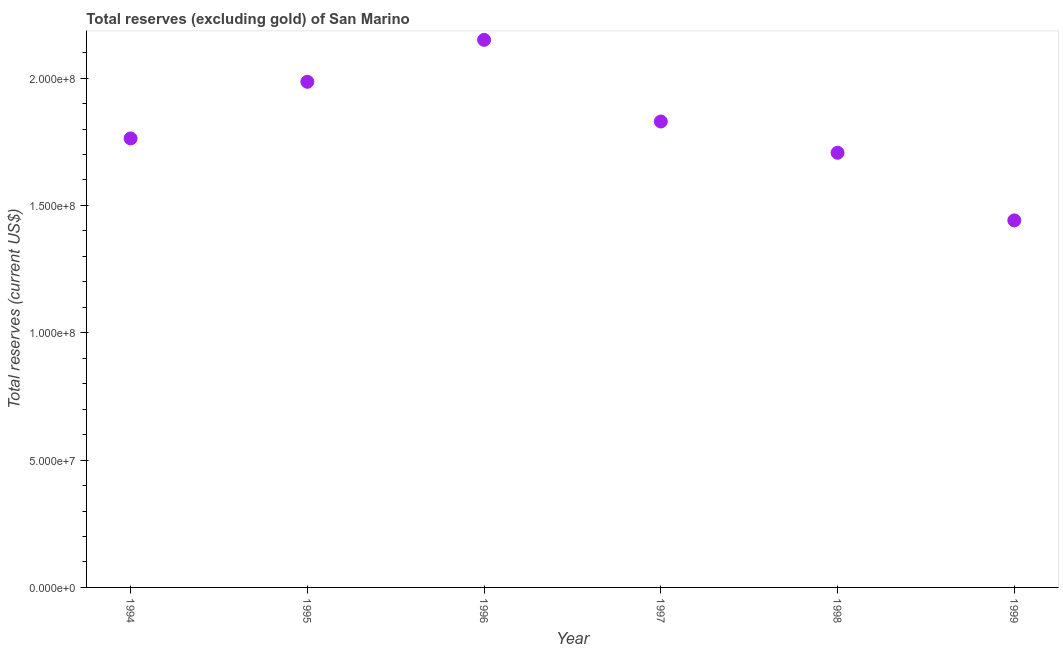What is the total reserves (excluding gold) in 1994?
Provide a short and direct response. 1.76e+08. Across all years, what is the maximum total reserves (excluding gold)?
Your answer should be very brief. 2.15e+08. Across all years, what is the minimum total reserves (excluding gold)?
Your answer should be very brief. 1.44e+08. In which year was the total reserves (excluding gold) maximum?
Offer a very short reply. 1996. In which year was the total reserves (excluding gold) minimum?
Your answer should be very brief. 1999. What is the sum of the total reserves (excluding gold)?
Provide a short and direct response. 1.09e+09. What is the difference between the total reserves (excluding gold) in 1998 and 1999?
Make the answer very short. 2.65e+07. What is the average total reserves (excluding gold) per year?
Keep it short and to the point. 1.81e+08. What is the median total reserves (excluding gold)?
Ensure brevity in your answer.  1.80e+08. In how many years, is the total reserves (excluding gold) greater than 70000000 US$?
Your answer should be compact. 6. Do a majority of the years between 1999 and 1994 (inclusive) have total reserves (excluding gold) greater than 60000000 US$?
Offer a very short reply. Yes. What is the ratio of the total reserves (excluding gold) in 1996 to that in 1997?
Your answer should be compact. 1.18. Is the total reserves (excluding gold) in 1995 less than that in 1996?
Your answer should be compact. Yes. What is the difference between the highest and the second highest total reserves (excluding gold)?
Offer a terse response. 1.65e+07. What is the difference between the highest and the lowest total reserves (excluding gold)?
Keep it short and to the point. 7.09e+07. What is the difference between two consecutive major ticks on the Y-axis?
Offer a very short reply. 5.00e+07. What is the title of the graph?
Your answer should be compact. Total reserves (excluding gold) of San Marino. What is the label or title of the X-axis?
Keep it short and to the point. Year. What is the label or title of the Y-axis?
Your answer should be very brief. Total reserves (current US$). What is the Total reserves (current US$) in 1994?
Make the answer very short. 1.76e+08. What is the Total reserves (current US$) in 1995?
Offer a very short reply. 1.99e+08. What is the Total reserves (current US$) in 1996?
Your answer should be compact. 2.15e+08. What is the Total reserves (current US$) in 1997?
Provide a succinct answer. 1.83e+08. What is the Total reserves (current US$) in 1998?
Your response must be concise. 1.71e+08. What is the Total reserves (current US$) in 1999?
Provide a short and direct response. 1.44e+08. What is the difference between the Total reserves (current US$) in 1994 and 1995?
Provide a succinct answer. -2.22e+07. What is the difference between the Total reserves (current US$) in 1994 and 1996?
Ensure brevity in your answer.  -3.87e+07. What is the difference between the Total reserves (current US$) in 1994 and 1997?
Provide a short and direct response. -6.64e+06. What is the difference between the Total reserves (current US$) in 1994 and 1998?
Offer a very short reply. 5.63e+06. What is the difference between the Total reserves (current US$) in 1994 and 1999?
Ensure brevity in your answer.  3.22e+07. What is the difference between the Total reserves (current US$) in 1995 and 1996?
Provide a short and direct response. -1.65e+07. What is the difference between the Total reserves (current US$) in 1995 and 1997?
Your answer should be very brief. 1.56e+07. What is the difference between the Total reserves (current US$) in 1995 and 1998?
Your response must be concise. 2.79e+07. What is the difference between the Total reserves (current US$) in 1995 and 1999?
Give a very brief answer. 5.44e+07. What is the difference between the Total reserves (current US$) in 1996 and 1997?
Give a very brief answer. 3.21e+07. What is the difference between the Total reserves (current US$) in 1996 and 1998?
Your answer should be very brief. 4.43e+07. What is the difference between the Total reserves (current US$) in 1996 and 1999?
Your response must be concise. 7.09e+07. What is the difference between the Total reserves (current US$) in 1997 and 1998?
Provide a succinct answer. 1.23e+07. What is the difference between the Total reserves (current US$) in 1997 and 1999?
Your answer should be compact. 3.88e+07. What is the difference between the Total reserves (current US$) in 1998 and 1999?
Your response must be concise. 2.65e+07. What is the ratio of the Total reserves (current US$) in 1994 to that in 1995?
Offer a very short reply. 0.89. What is the ratio of the Total reserves (current US$) in 1994 to that in 1996?
Your answer should be compact. 0.82. What is the ratio of the Total reserves (current US$) in 1994 to that in 1997?
Provide a short and direct response. 0.96. What is the ratio of the Total reserves (current US$) in 1994 to that in 1998?
Your answer should be very brief. 1.03. What is the ratio of the Total reserves (current US$) in 1994 to that in 1999?
Your response must be concise. 1.22. What is the ratio of the Total reserves (current US$) in 1995 to that in 1996?
Give a very brief answer. 0.92. What is the ratio of the Total reserves (current US$) in 1995 to that in 1997?
Make the answer very short. 1.08. What is the ratio of the Total reserves (current US$) in 1995 to that in 1998?
Offer a terse response. 1.16. What is the ratio of the Total reserves (current US$) in 1995 to that in 1999?
Provide a short and direct response. 1.38. What is the ratio of the Total reserves (current US$) in 1996 to that in 1997?
Your answer should be compact. 1.18. What is the ratio of the Total reserves (current US$) in 1996 to that in 1998?
Your response must be concise. 1.26. What is the ratio of the Total reserves (current US$) in 1996 to that in 1999?
Make the answer very short. 1.49. What is the ratio of the Total reserves (current US$) in 1997 to that in 1998?
Make the answer very short. 1.07. What is the ratio of the Total reserves (current US$) in 1997 to that in 1999?
Provide a short and direct response. 1.27. What is the ratio of the Total reserves (current US$) in 1998 to that in 1999?
Your answer should be very brief. 1.18. 